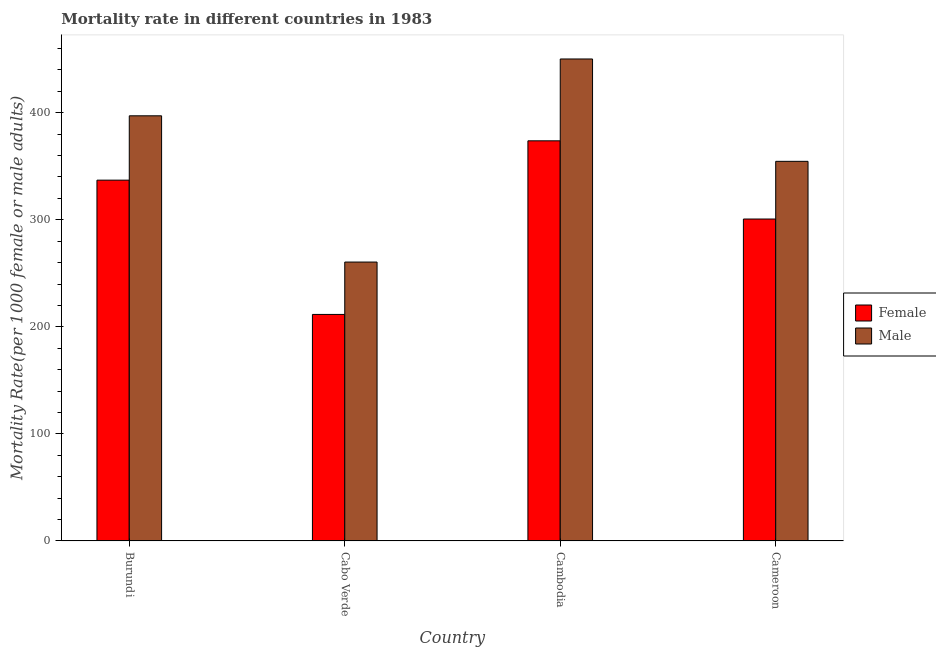How many different coloured bars are there?
Provide a short and direct response. 2. How many groups of bars are there?
Keep it short and to the point. 4. What is the label of the 4th group of bars from the left?
Provide a short and direct response. Cameroon. What is the male mortality rate in Burundi?
Give a very brief answer. 397.12. Across all countries, what is the maximum male mortality rate?
Ensure brevity in your answer.  450.21. Across all countries, what is the minimum female mortality rate?
Your answer should be very brief. 211.58. In which country was the female mortality rate maximum?
Give a very brief answer. Cambodia. In which country was the male mortality rate minimum?
Give a very brief answer. Cabo Verde. What is the total female mortality rate in the graph?
Make the answer very short. 1223.06. What is the difference between the male mortality rate in Cambodia and that in Cameroon?
Offer a terse response. 95.62. What is the difference between the male mortality rate in Burundi and the female mortality rate in Cabo Verde?
Your answer should be very brief. 185.54. What is the average female mortality rate per country?
Your response must be concise. 305.77. What is the difference between the female mortality rate and male mortality rate in Cameroon?
Your answer should be compact. -53.89. In how many countries, is the male mortality rate greater than 180 ?
Make the answer very short. 4. What is the ratio of the male mortality rate in Burundi to that in Cambodia?
Make the answer very short. 0.88. Is the female mortality rate in Burundi less than that in Cambodia?
Your answer should be compact. Yes. Is the difference between the male mortality rate in Cabo Verde and Cameroon greater than the difference between the female mortality rate in Cabo Verde and Cameroon?
Ensure brevity in your answer.  No. What is the difference between the highest and the second highest male mortality rate?
Give a very brief answer. 53.09. What is the difference between the highest and the lowest male mortality rate?
Provide a short and direct response. 189.7. In how many countries, is the male mortality rate greater than the average male mortality rate taken over all countries?
Your answer should be compact. 2. Is the sum of the male mortality rate in Cabo Verde and Cameroon greater than the maximum female mortality rate across all countries?
Ensure brevity in your answer.  Yes. What does the 2nd bar from the left in Burundi represents?
Keep it short and to the point. Male. What does the 2nd bar from the right in Burundi represents?
Make the answer very short. Female. Are all the bars in the graph horizontal?
Offer a terse response. No. How many countries are there in the graph?
Make the answer very short. 4. Where does the legend appear in the graph?
Make the answer very short. Center right. How are the legend labels stacked?
Offer a terse response. Vertical. What is the title of the graph?
Ensure brevity in your answer.  Mortality rate in different countries in 1983. Does "All education staff compensation" appear as one of the legend labels in the graph?
Make the answer very short. No. What is the label or title of the Y-axis?
Ensure brevity in your answer.  Mortality Rate(per 1000 female or male adults). What is the Mortality Rate(per 1000 female or male adults) in Female in Burundi?
Your answer should be very brief. 337.02. What is the Mortality Rate(per 1000 female or male adults) of Male in Burundi?
Keep it short and to the point. 397.12. What is the Mortality Rate(per 1000 female or male adults) in Female in Cabo Verde?
Offer a very short reply. 211.58. What is the Mortality Rate(per 1000 female or male adults) in Male in Cabo Verde?
Offer a terse response. 260.51. What is the Mortality Rate(per 1000 female or male adults) of Female in Cambodia?
Provide a succinct answer. 373.76. What is the Mortality Rate(per 1000 female or male adults) in Male in Cambodia?
Your response must be concise. 450.21. What is the Mortality Rate(per 1000 female or male adults) in Female in Cameroon?
Keep it short and to the point. 300.7. What is the Mortality Rate(per 1000 female or male adults) in Male in Cameroon?
Make the answer very short. 354.6. Across all countries, what is the maximum Mortality Rate(per 1000 female or male adults) in Female?
Ensure brevity in your answer.  373.76. Across all countries, what is the maximum Mortality Rate(per 1000 female or male adults) of Male?
Make the answer very short. 450.21. Across all countries, what is the minimum Mortality Rate(per 1000 female or male adults) of Female?
Offer a very short reply. 211.58. Across all countries, what is the minimum Mortality Rate(per 1000 female or male adults) of Male?
Ensure brevity in your answer.  260.51. What is the total Mortality Rate(per 1000 female or male adults) of Female in the graph?
Offer a terse response. 1223.06. What is the total Mortality Rate(per 1000 female or male adults) of Male in the graph?
Keep it short and to the point. 1462.44. What is the difference between the Mortality Rate(per 1000 female or male adults) in Female in Burundi and that in Cabo Verde?
Your response must be concise. 125.44. What is the difference between the Mortality Rate(per 1000 female or male adults) in Male in Burundi and that in Cabo Verde?
Offer a very short reply. 136.61. What is the difference between the Mortality Rate(per 1000 female or male adults) of Female in Burundi and that in Cambodia?
Your answer should be compact. -36.74. What is the difference between the Mortality Rate(per 1000 female or male adults) of Male in Burundi and that in Cambodia?
Your response must be concise. -53.09. What is the difference between the Mortality Rate(per 1000 female or male adults) of Female in Burundi and that in Cameroon?
Give a very brief answer. 36.32. What is the difference between the Mortality Rate(per 1000 female or male adults) in Male in Burundi and that in Cameroon?
Provide a short and direct response. 42.53. What is the difference between the Mortality Rate(per 1000 female or male adults) of Female in Cabo Verde and that in Cambodia?
Provide a succinct answer. -162.18. What is the difference between the Mortality Rate(per 1000 female or male adults) of Male in Cabo Verde and that in Cambodia?
Make the answer very short. -189.7. What is the difference between the Mortality Rate(per 1000 female or male adults) of Female in Cabo Verde and that in Cameroon?
Offer a very short reply. -89.12. What is the difference between the Mortality Rate(per 1000 female or male adults) in Male in Cabo Verde and that in Cameroon?
Offer a terse response. -94.08. What is the difference between the Mortality Rate(per 1000 female or male adults) of Female in Cambodia and that in Cameroon?
Your answer should be very brief. 73.06. What is the difference between the Mortality Rate(per 1000 female or male adults) in Male in Cambodia and that in Cameroon?
Give a very brief answer. 95.62. What is the difference between the Mortality Rate(per 1000 female or male adults) of Female in Burundi and the Mortality Rate(per 1000 female or male adults) of Male in Cabo Verde?
Offer a very short reply. 76.51. What is the difference between the Mortality Rate(per 1000 female or male adults) in Female in Burundi and the Mortality Rate(per 1000 female or male adults) in Male in Cambodia?
Offer a very short reply. -113.19. What is the difference between the Mortality Rate(per 1000 female or male adults) in Female in Burundi and the Mortality Rate(per 1000 female or male adults) in Male in Cameroon?
Ensure brevity in your answer.  -17.57. What is the difference between the Mortality Rate(per 1000 female or male adults) of Female in Cabo Verde and the Mortality Rate(per 1000 female or male adults) of Male in Cambodia?
Your answer should be compact. -238.63. What is the difference between the Mortality Rate(per 1000 female or male adults) in Female in Cabo Verde and the Mortality Rate(per 1000 female or male adults) in Male in Cameroon?
Provide a short and direct response. -143.02. What is the difference between the Mortality Rate(per 1000 female or male adults) in Female in Cambodia and the Mortality Rate(per 1000 female or male adults) in Male in Cameroon?
Your response must be concise. 19.16. What is the average Mortality Rate(per 1000 female or male adults) of Female per country?
Give a very brief answer. 305.77. What is the average Mortality Rate(per 1000 female or male adults) in Male per country?
Your answer should be compact. 365.61. What is the difference between the Mortality Rate(per 1000 female or male adults) in Female and Mortality Rate(per 1000 female or male adults) in Male in Burundi?
Provide a succinct answer. -60.1. What is the difference between the Mortality Rate(per 1000 female or male adults) in Female and Mortality Rate(per 1000 female or male adults) in Male in Cabo Verde?
Ensure brevity in your answer.  -48.93. What is the difference between the Mortality Rate(per 1000 female or male adults) in Female and Mortality Rate(per 1000 female or male adults) in Male in Cambodia?
Offer a very short reply. -76.45. What is the difference between the Mortality Rate(per 1000 female or male adults) in Female and Mortality Rate(per 1000 female or male adults) in Male in Cameroon?
Ensure brevity in your answer.  -53.89. What is the ratio of the Mortality Rate(per 1000 female or male adults) in Female in Burundi to that in Cabo Verde?
Give a very brief answer. 1.59. What is the ratio of the Mortality Rate(per 1000 female or male adults) of Male in Burundi to that in Cabo Verde?
Ensure brevity in your answer.  1.52. What is the ratio of the Mortality Rate(per 1000 female or male adults) in Female in Burundi to that in Cambodia?
Give a very brief answer. 0.9. What is the ratio of the Mortality Rate(per 1000 female or male adults) of Male in Burundi to that in Cambodia?
Give a very brief answer. 0.88. What is the ratio of the Mortality Rate(per 1000 female or male adults) in Female in Burundi to that in Cameroon?
Offer a very short reply. 1.12. What is the ratio of the Mortality Rate(per 1000 female or male adults) of Male in Burundi to that in Cameroon?
Your response must be concise. 1.12. What is the ratio of the Mortality Rate(per 1000 female or male adults) of Female in Cabo Verde to that in Cambodia?
Your response must be concise. 0.57. What is the ratio of the Mortality Rate(per 1000 female or male adults) in Male in Cabo Verde to that in Cambodia?
Offer a very short reply. 0.58. What is the ratio of the Mortality Rate(per 1000 female or male adults) of Female in Cabo Verde to that in Cameroon?
Provide a short and direct response. 0.7. What is the ratio of the Mortality Rate(per 1000 female or male adults) of Male in Cabo Verde to that in Cameroon?
Provide a short and direct response. 0.73. What is the ratio of the Mortality Rate(per 1000 female or male adults) of Female in Cambodia to that in Cameroon?
Keep it short and to the point. 1.24. What is the ratio of the Mortality Rate(per 1000 female or male adults) of Male in Cambodia to that in Cameroon?
Ensure brevity in your answer.  1.27. What is the difference between the highest and the second highest Mortality Rate(per 1000 female or male adults) of Female?
Make the answer very short. 36.74. What is the difference between the highest and the second highest Mortality Rate(per 1000 female or male adults) in Male?
Provide a short and direct response. 53.09. What is the difference between the highest and the lowest Mortality Rate(per 1000 female or male adults) in Female?
Keep it short and to the point. 162.18. What is the difference between the highest and the lowest Mortality Rate(per 1000 female or male adults) in Male?
Offer a terse response. 189.7. 